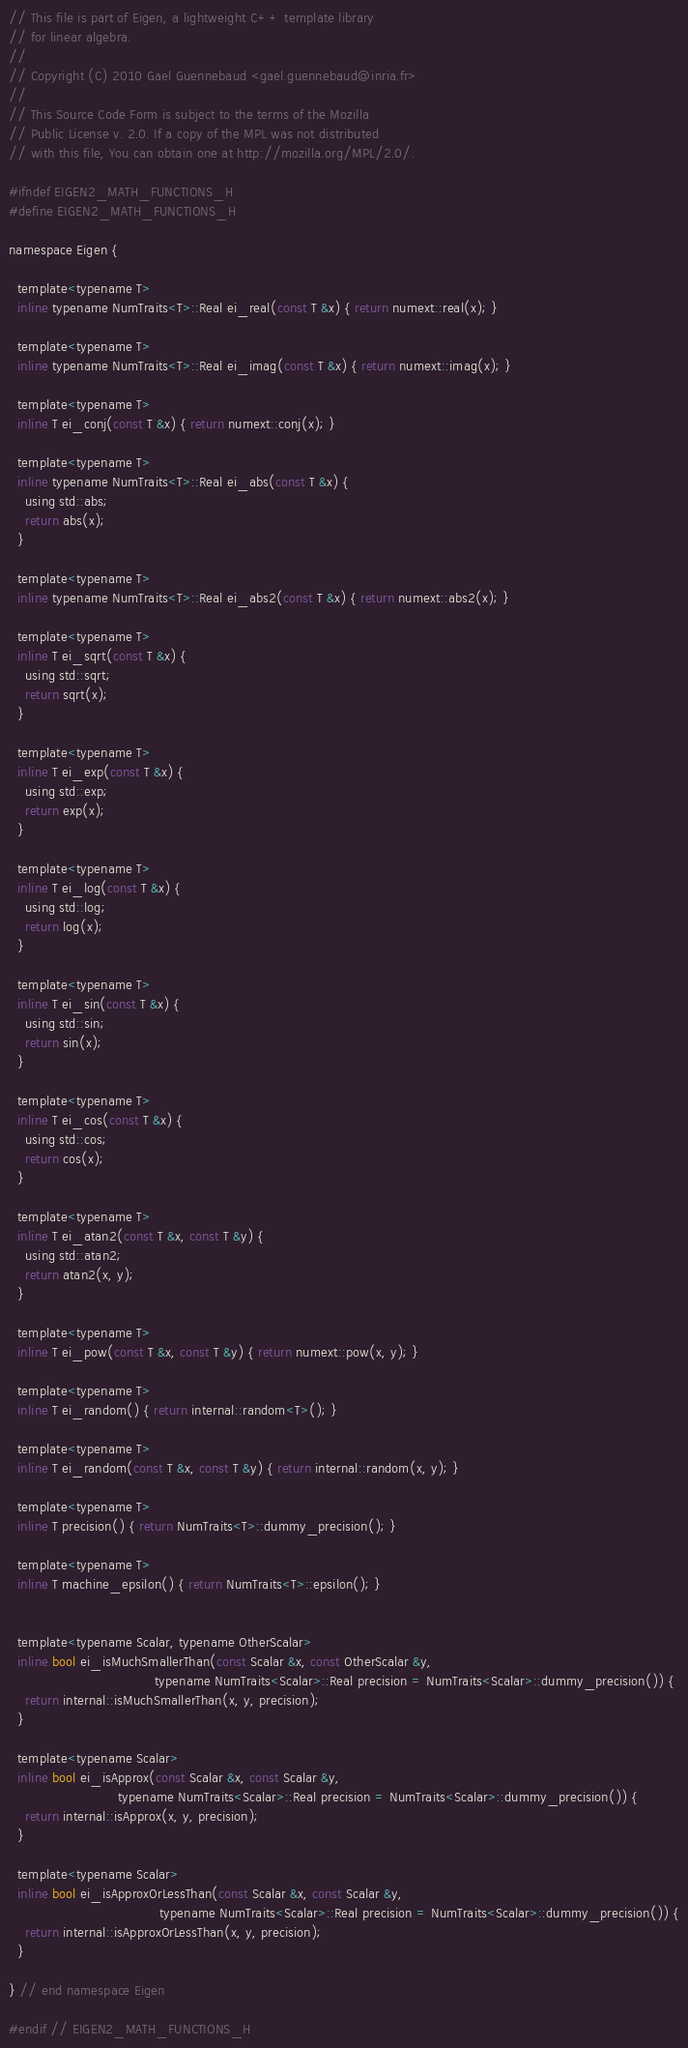<code> <loc_0><loc_0><loc_500><loc_500><_C_>// This file is part of Eigen, a lightweight C++ template library
// for linear algebra.
//
// Copyright (C) 2010 Gael Guennebaud <gael.guennebaud@inria.fr>
//
// This Source Code Form is subject to the terms of the Mozilla
// Public License v. 2.0. If a copy of the MPL was not distributed
// with this file, You can obtain one at http://mozilla.org/MPL/2.0/.

#ifndef EIGEN2_MATH_FUNCTIONS_H
#define EIGEN2_MATH_FUNCTIONS_H

namespace Eigen {

  template<typename T>
  inline typename NumTraits<T>::Real ei_real(const T &x) { return numext::real(x); }

  template<typename T>
  inline typename NumTraits<T>::Real ei_imag(const T &x) { return numext::imag(x); }

  template<typename T>
  inline T ei_conj(const T &x) { return numext::conj(x); }

  template<typename T>
  inline typename NumTraits<T>::Real ei_abs(const T &x) {
    using std::abs;
    return abs(x);
  }

  template<typename T>
  inline typename NumTraits<T>::Real ei_abs2(const T &x) { return numext::abs2(x); }

  template<typename T>
  inline T ei_sqrt(const T &x) {
    using std::sqrt;
    return sqrt(x);
  }

  template<typename T>
  inline T ei_exp(const T &x) {
    using std::exp;
    return exp(x);
  }

  template<typename T>
  inline T ei_log(const T &x) {
    using std::log;
    return log(x);
  }

  template<typename T>
  inline T ei_sin(const T &x) {
    using std::sin;
    return sin(x);
  }

  template<typename T>
  inline T ei_cos(const T &x) {
    using std::cos;
    return cos(x);
  }

  template<typename T>
  inline T ei_atan2(const T &x, const T &y) {
    using std::atan2;
    return atan2(x, y);
  }

  template<typename T>
  inline T ei_pow(const T &x, const T &y) { return numext::pow(x, y); }

  template<typename T>
  inline T ei_random() { return internal::random<T>(); }

  template<typename T>
  inline T ei_random(const T &x, const T &y) { return internal::random(x, y); }

  template<typename T>
  inline T precision() { return NumTraits<T>::dummy_precision(); }

  template<typename T>
  inline T machine_epsilon() { return NumTraits<T>::epsilon(); }


  template<typename Scalar, typename OtherScalar>
  inline bool ei_isMuchSmallerThan(const Scalar &x, const OtherScalar &y,
                                   typename NumTraits<Scalar>::Real precision = NumTraits<Scalar>::dummy_precision()) {
    return internal::isMuchSmallerThan(x, y, precision);
  }

  template<typename Scalar>
  inline bool ei_isApprox(const Scalar &x, const Scalar &y,
                          typename NumTraits<Scalar>::Real precision = NumTraits<Scalar>::dummy_precision()) {
    return internal::isApprox(x, y, precision);
  }

  template<typename Scalar>
  inline bool ei_isApproxOrLessThan(const Scalar &x, const Scalar &y,
                                    typename NumTraits<Scalar>::Real precision = NumTraits<Scalar>::dummy_precision()) {
    return internal::isApproxOrLessThan(x, y, precision);
  }

} // end namespace Eigen

#endif // EIGEN2_MATH_FUNCTIONS_H
</code> 